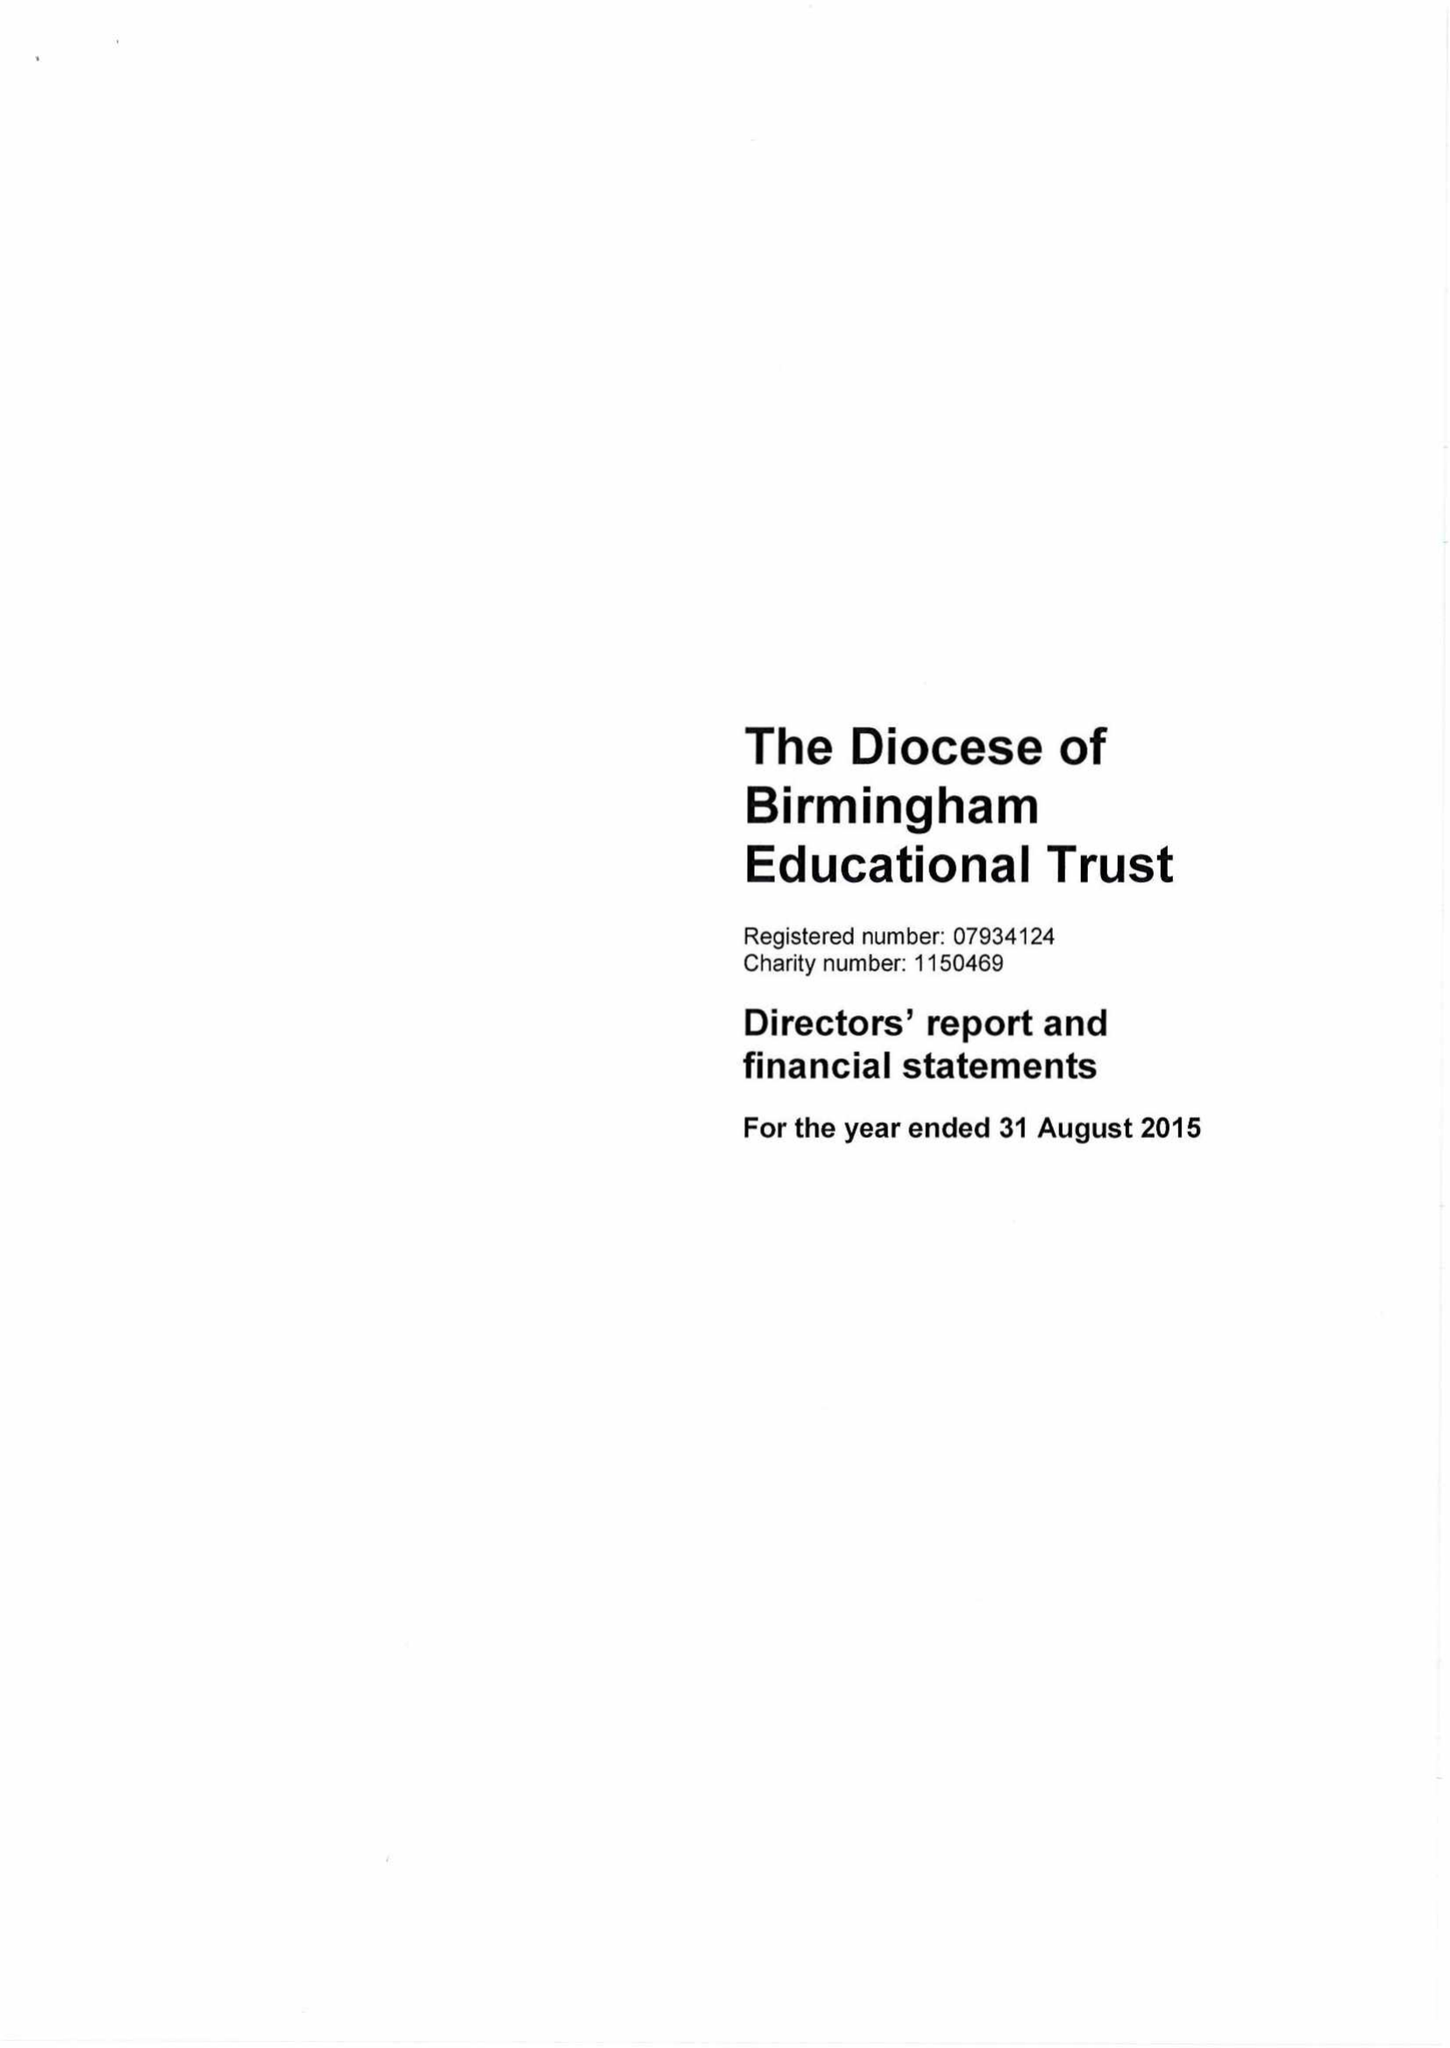What is the value for the address__postcode?
Answer the question using a single word or phrase. B3 2BJ 